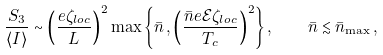<formula> <loc_0><loc_0><loc_500><loc_500>\frac { S _ { 3 } } { \langle { I } \rangle } \sim \left ( \frac { e \zeta _ { l o c } } L \right ) ^ { 2 } \max \left \{ \bar { n } \, , \left ( \frac { \bar { n } e \mathcal { E } \zeta _ { l o c } } { T _ { c } } \right ) ^ { 2 } \right \} , \quad \bar { n } \lesssim \bar { n } _ { \max } \, ,</formula> 